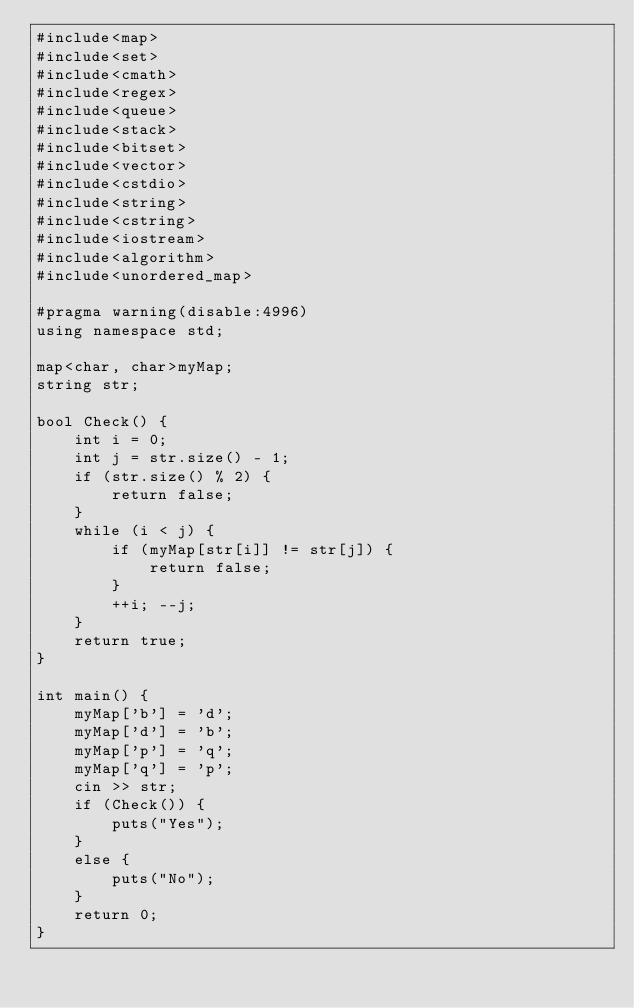Convert code to text. <code><loc_0><loc_0><loc_500><loc_500><_C++_>#include<map>
#include<set>
#include<cmath>
#include<regex>
#include<queue>
#include<stack>
#include<bitset>
#include<vector>
#include<cstdio>
#include<string>
#include<cstring>
#include<iostream>
#include<algorithm>
#include<unordered_map>

#pragma warning(disable:4996)
using namespace std;

map<char, char>myMap;
string str;

bool Check() {
	int i = 0;
	int j = str.size() - 1;
	if (str.size() % 2) {
		return false;
	}
	while (i < j) {
		if (myMap[str[i]] != str[j]) {
			return false;
		}
		++i; --j;
	}
	return true;
}

int main() {	
	myMap['b'] = 'd';
	myMap['d'] = 'b';
	myMap['p'] = 'q';
	myMap['q'] = 'p';
	cin >> str;
	if (Check()) {
		puts("Yes");
	}
	else {
		puts("No");
	}
	return 0;
}</code> 